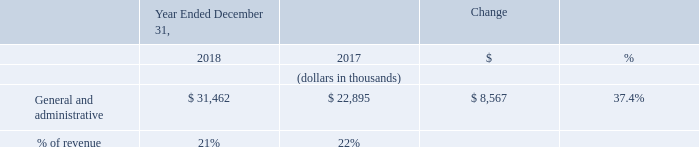General and Administrative Expense
General and administrative expense increased by $8.6 million in 2018 compared to 2017. The increase was primarily due to a $3.7 million increase in employee-related costs, which includes stock-based compensation, associated with our increased headcount from 79 employees as of December 31, 2017 to 89 employees as of December 31, 2018. There was an additional increase of $2.8 million in depreciation and amortization, an increase of $1.5 million to support compliance as a public company, an increase of $0.4 million in software subscription cost and a $0.2 million increase in office related expenses to support the administrative team.
What was the increase in the General and administrative in 2018? $8.6 million. What was the General and administrative in 2018 and 2017?
Answer scale should be: thousand. 31,462, 22,895. What was the increase in depreciation and amortization from 2017 to 2018? $2.8 million. What is the average General and administrative expense for 2017 and 2018?
Answer scale should be: thousand. (31,462 + 22,895) / 2
Answer: 27178.5. In which year was General and administrative expense less than 40,000 thousands? Locate and analyze general and administrative in row 4
answer: 2018, 2017. What is the change in the gross margin between 2017 and 2018?
Answer scale should be: thousand. 21 - 22
Answer: -1. 